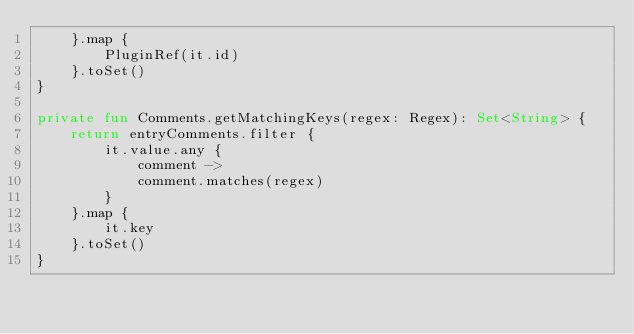Convert code to text. <code><loc_0><loc_0><loc_500><loc_500><_Kotlin_>    }.map {
        PluginRef(it.id)
    }.toSet()
}

private fun Comments.getMatchingKeys(regex: Regex): Set<String> {
    return entryComments.filter {
        it.value.any {
            comment ->
            comment.matches(regex)
        }
    }.map {
        it.key
    }.toSet()
}
</code> 